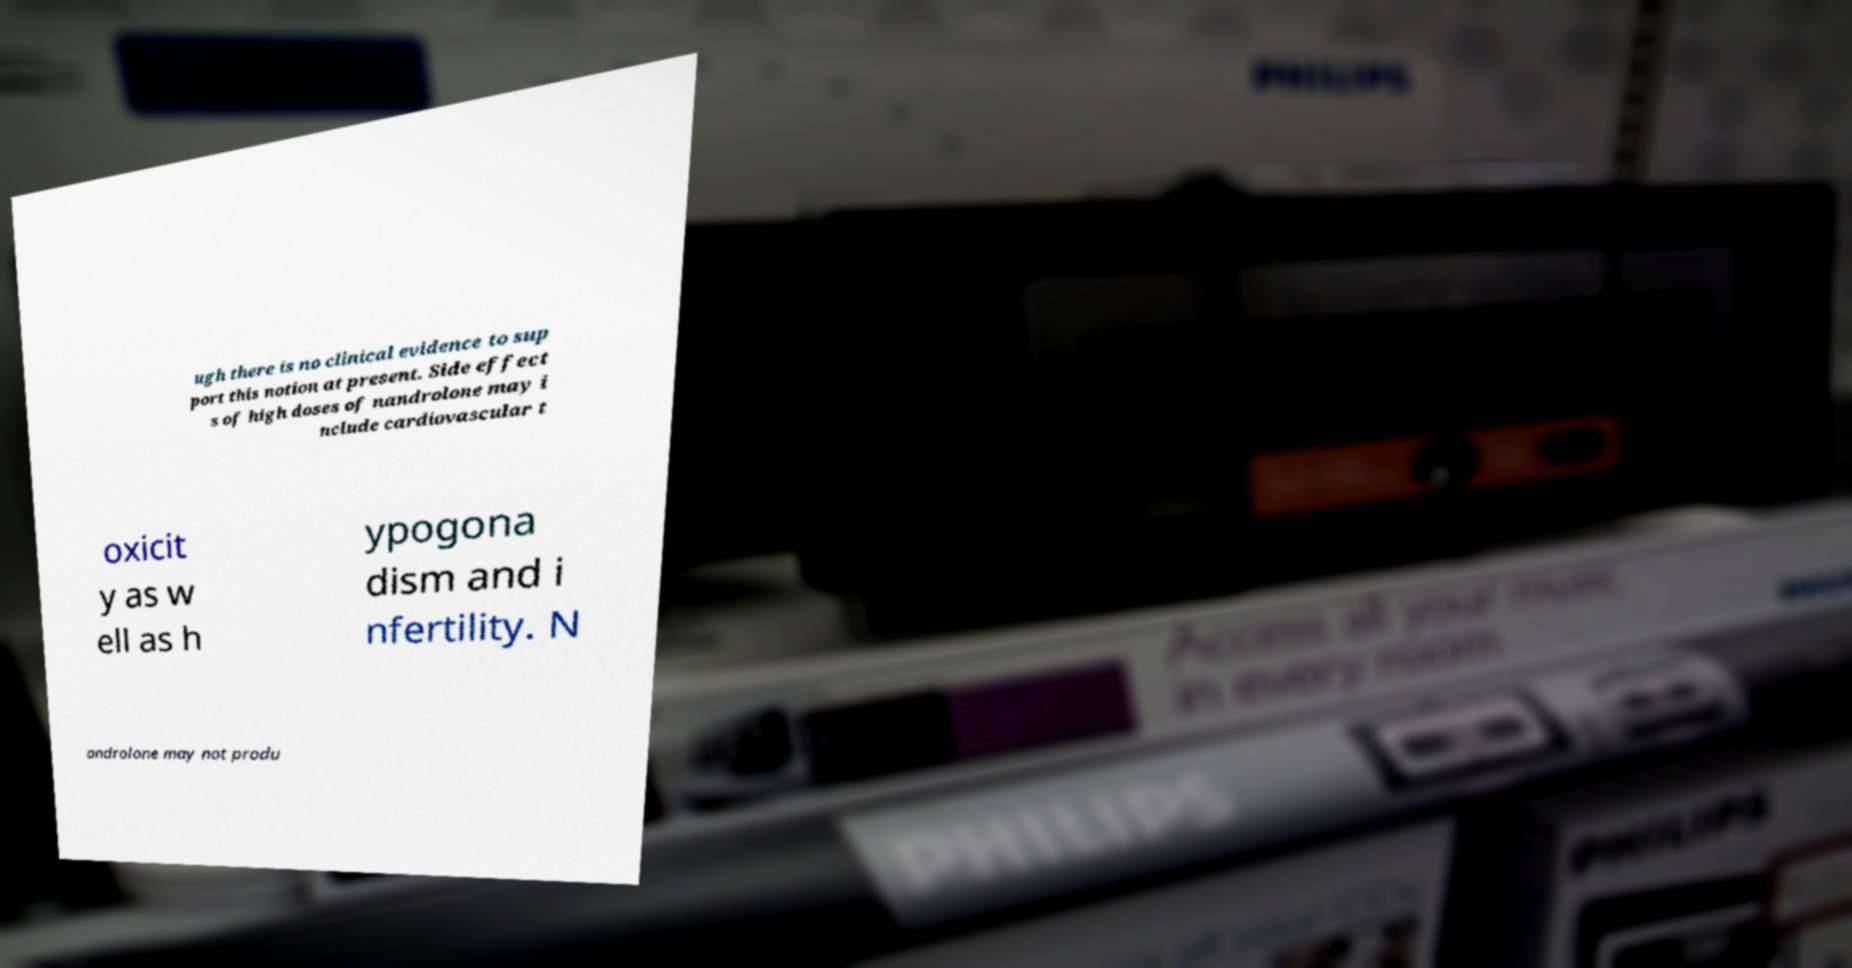Please identify and transcribe the text found in this image. ugh there is no clinical evidence to sup port this notion at present. Side effect s of high doses of nandrolone may i nclude cardiovascular t oxicit y as w ell as h ypogona dism and i nfertility. N androlone may not produ 